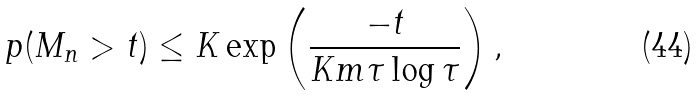Convert formula to latex. <formula><loc_0><loc_0><loc_500><loc_500>\ p ( M _ { n } > t ) \leq K \exp \left ( \frac { - t } { K m \tau \log \tau } \right ) ,</formula> 